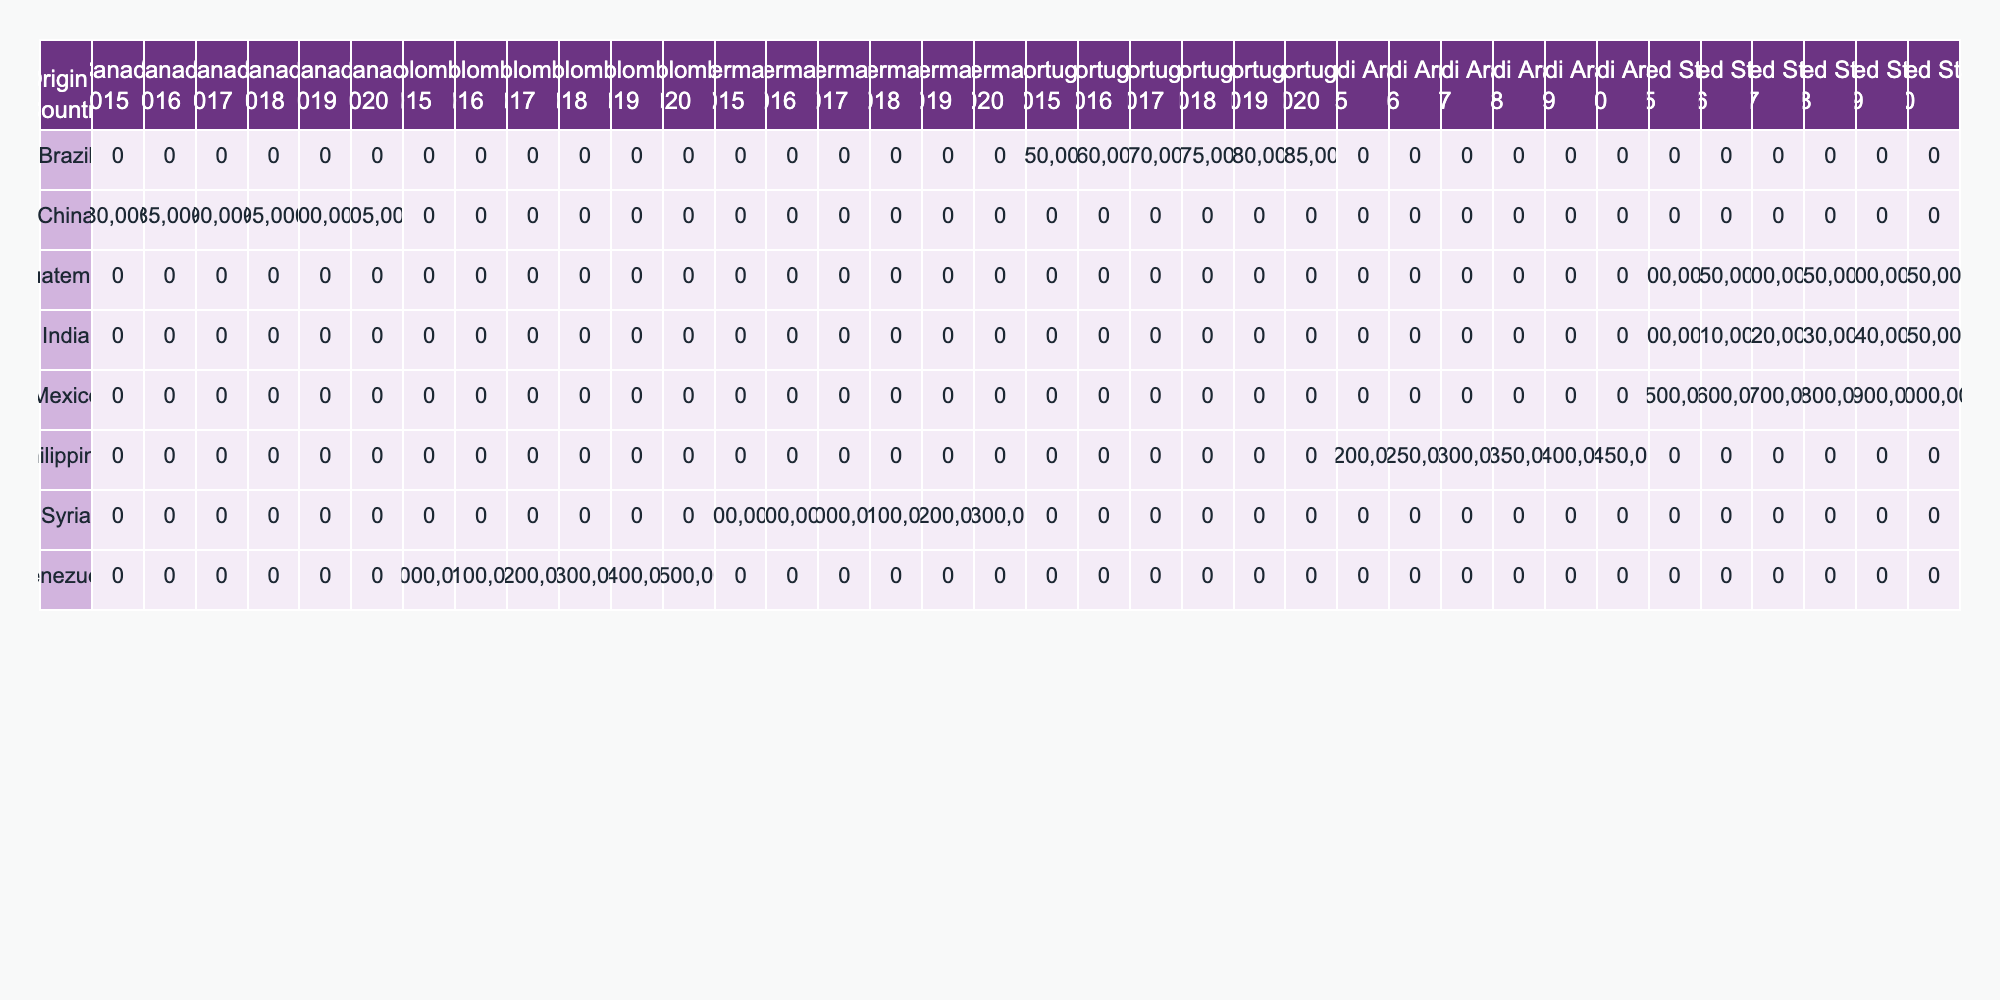What was the highest number of migrants from Mexico to the United States between 2015 and 2020? Looking at the table, the highest number is in 2020 with 2,000,000 migrants.
Answer: 2,000,000 Which country had the most migrants to Saudi Arabia in 2017? From the table, the Philippines had 1,300,000 migrants to Saudi Arabia in 2017, which is the highest number for that year.
Answer: Philippines How many migrants moved from India to the United States in total from 2015 to 2020? Summing the migrants from India to the United States across the years: 200,000 (2015) + 210,000 (2016) + 220,000 (2017) + 230,000 (2018) + 240,000 (2019) + 250,000 (2020) gives a total of 1,410,000 migrants.
Answer: 1,410,000 Is the number of migrants from Guatemala to the United States consistently increasing from 2015 to 2020? By the table values, the number of Guatemalan migrants is: 700,000 (2015), 750,000 (2016), 800,000 (2017), 850,000 (2018), 900,000 (2019), and 950,000 (2020), which shows a consistent increase.
Answer: Yes What was the average number of migrants from Venezuela to Colombia from 2015 to 2020? The total number of migrants from Venezuela to Colombia is 1,000,000 (2015) + 1,100,000 (2016) + 1,200,000 (2017) + 1,300,000 (2018) + 1,400,000 (2019) + 1,500,000 (2020) = 7,500,000. Dividing by 6 years gives an average of 1,250,000 migrants.
Answer: 1,250,000 Was there ever a decrease in the number of migrants from China to Canada from 2015 to 2020? Checking the data from the table, the numbers are: 80,000 (2015), 85,000 (2016), 90,000 (2017), 95,000 (2018), 100,000 (2019), and 105,000 (2020). This shows a consistent increase without any decrease.
Answer: No Which destination country received the highest total number of migrants from Mexico between 2015 to 2020? For Mexico to the United States, the total is 1,500,000 (2015) + 1,600,000 (2016) + 1,700,000 (2017) + 1,800,000 (2018) + 1,900,000 (2019) + 2,000,000 (2020) = 10,500,000 which is higher than any other destination.
Answer: United States How many more migrants moved from the Philippines to Saudi Arabia in 2019 compared to 2015? The difference is calculated by taking the migrants in 2019 (1,400,000) and subtracting those in 2015 (1,200,000). That provides a value of 200,000 more migrants in 2019.
Answer: 200,000 Did the total number of migrants from Syria to Germany exceed 1 million in any year? Referring to the table, the number of Syrian migrants to Germany exceeded 1 million in 2016 (900,000), 2017 (1,000,000), 2018 (1,100,000), 2019 (1,200,000), and 2020 (1,300,000).
Answer: Yes What was the change in the number of migrants from Brazil to Portugal from 2015 to 2020? The numbers for Brazil to Portugal are: 150,000 (2015), 160,000 (2016), 170,000 (2017), 175,000 (2018), 180,000 (2019), and 185,000 (2020). This shows an increase from 150,000 to 185,000, providing a change of 35,000.
Answer: Increased by 35,000 